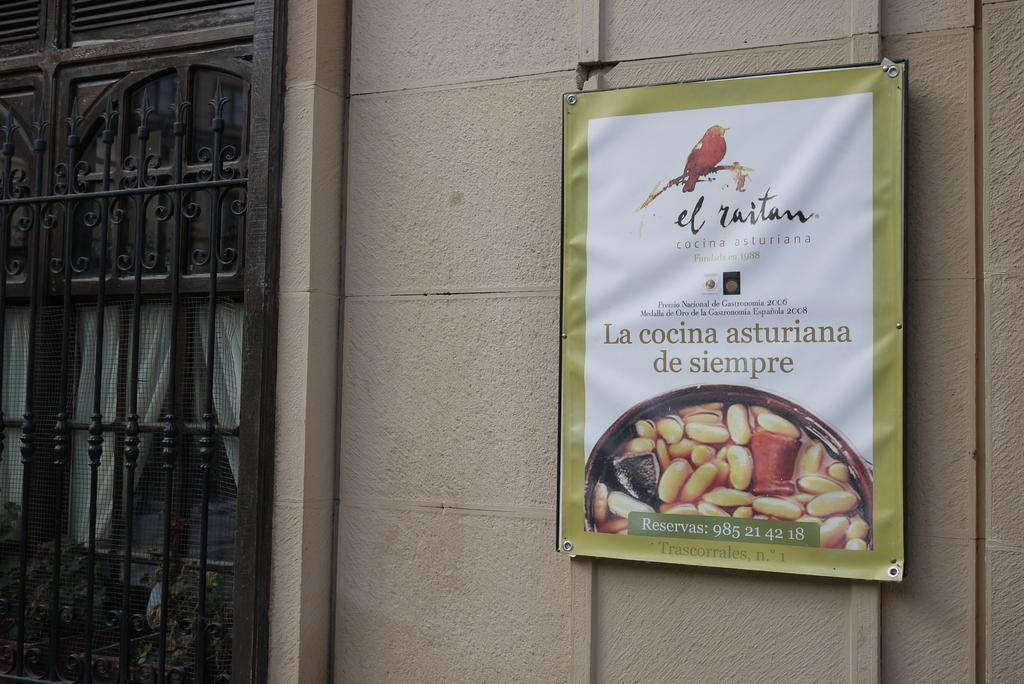What is hanging in the image? There is a banner in the image. What is attached to the wall in the image? There is a board attached to the wall in the image. What can be used to control access in the image? There is a gate in the image. What type of window treatment is present in the image? There are curtains in the image. How many legs can be seen on the banner in the image? Banners do not have legs, so none can be seen on the banner in the image. 